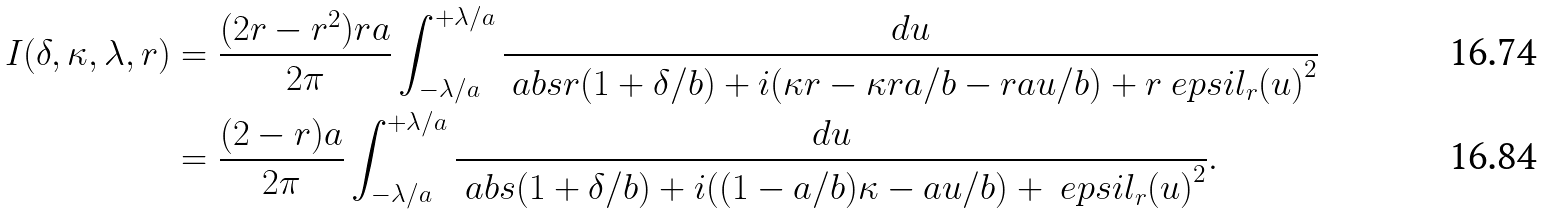<formula> <loc_0><loc_0><loc_500><loc_500>I ( \delta , \kappa , \lambda , r ) & = \frac { ( 2 r - r ^ { 2 } ) r a } { 2 \pi } \int _ { - \lambda / a } ^ { + \lambda / a } \frac { d u } { \ a b s { r ( 1 + \delta / b ) + i ( \kappa r - \kappa r a / b - r a u / b ) + r \ e p s i l _ { r } ( u ) } ^ { 2 } } \\ & = \frac { ( 2 - r ) a } { 2 \pi } \int _ { - \lambda / a } ^ { + \lambda / a } \frac { d u } { \ a b s { ( 1 + \delta / b ) + i ( ( 1 - a / b ) \kappa - a u / b ) + \ e p s i l _ { r } ( u ) } ^ { 2 } } .</formula> 